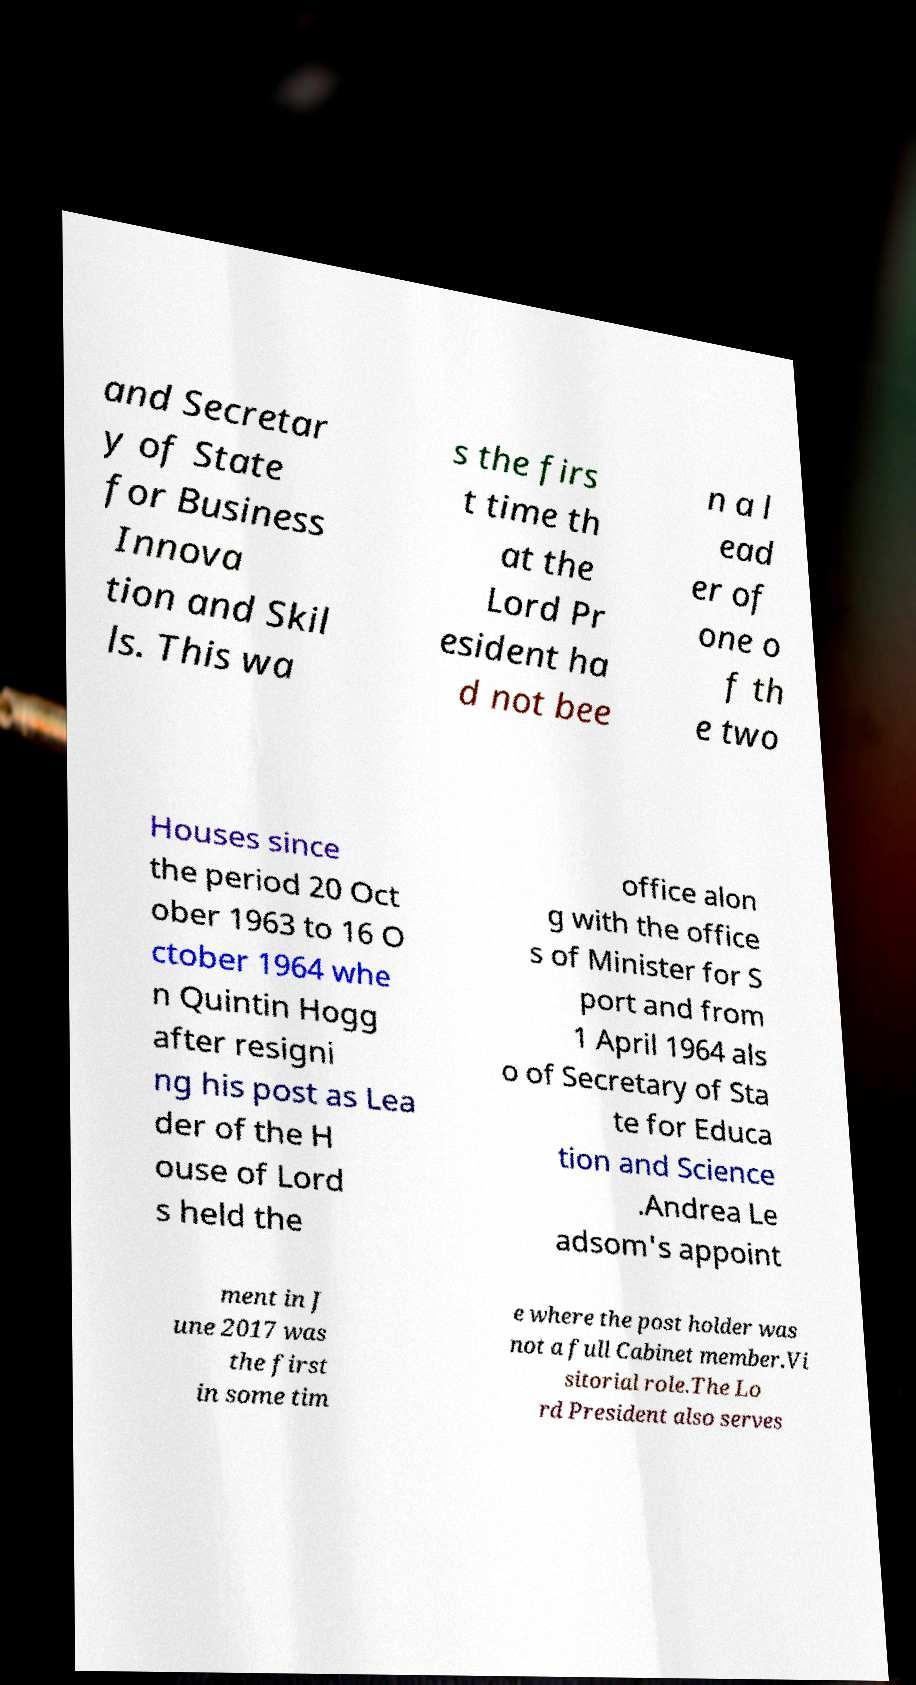Can you read and provide the text displayed in the image?This photo seems to have some interesting text. Can you extract and type it out for me? and Secretar y of State for Business Innova tion and Skil ls. This wa s the firs t time th at the Lord Pr esident ha d not bee n a l ead er of one o f th e two Houses since the period 20 Oct ober 1963 to 16 O ctober 1964 whe n Quintin Hogg after resigni ng his post as Lea der of the H ouse of Lord s held the office alon g with the office s of Minister for S port and from 1 April 1964 als o of Secretary of Sta te for Educa tion and Science .Andrea Le adsom's appoint ment in J une 2017 was the first in some tim e where the post holder was not a full Cabinet member.Vi sitorial role.The Lo rd President also serves 